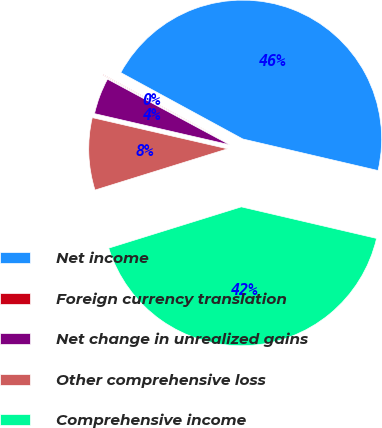Convert chart to OTSL. <chart><loc_0><loc_0><loc_500><loc_500><pie_chart><fcel>Net income<fcel>Foreign currency translation<fcel>Net change in unrealized gains<fcel>Other comprehensive loss<fcel>Comprehensive income<nl><fcel>45.72%<fcel>0.08%<fcel>4.24%<fcel>8.41%<fcel>41.55%<nl></chart> 